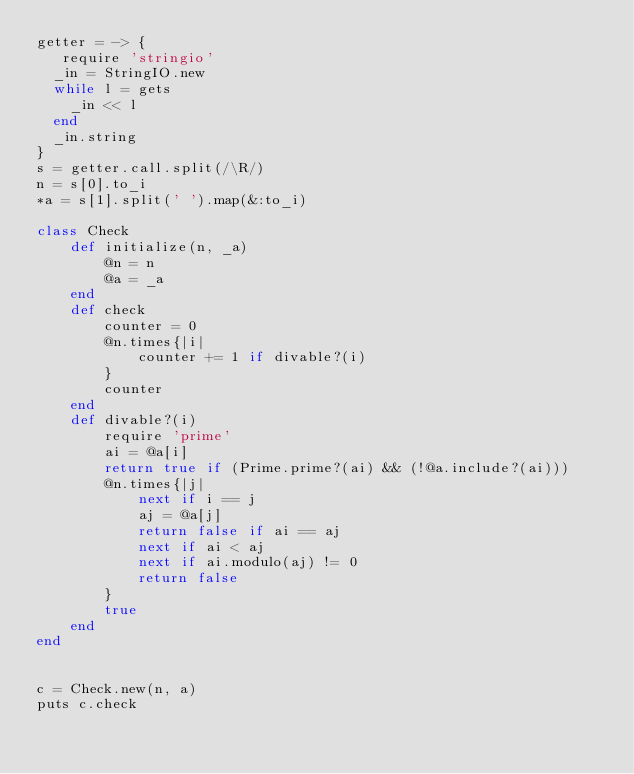<code> <loc_0><loc_0><loc_500><loc_500><_Ruby_>getter = -> {
   require 'stringio'
  _in = StringIO.new
  while l = gets
    _in << l
  end
  _in.string
}
s = getter.call.split(/\R/)
n = s[0].to_i
*a = s[1].split(' ').map(&:to_i)

class Check
    def initialize(n, _a)
        @n = n
        @a = _a
    end
    def check
        counter = 0
        @n.times{|i|
            counter += 1 if divable?(i)
        }
        counter
    end
    def divable?(i)
        require 'prime'
        ai = @a[i]
        return true if (Prime.prime?(ai) && (!@a.include?(ai)))
        @n.times{|j|
            next if i == j
            aj = @a[j]
            return false if ai == aj
            next if ai < aj
            next if ai.modulo(aj) != 0
            return false
        }
        true
    end
end


c = Check.new(n, a)
puts c.check

</code> 